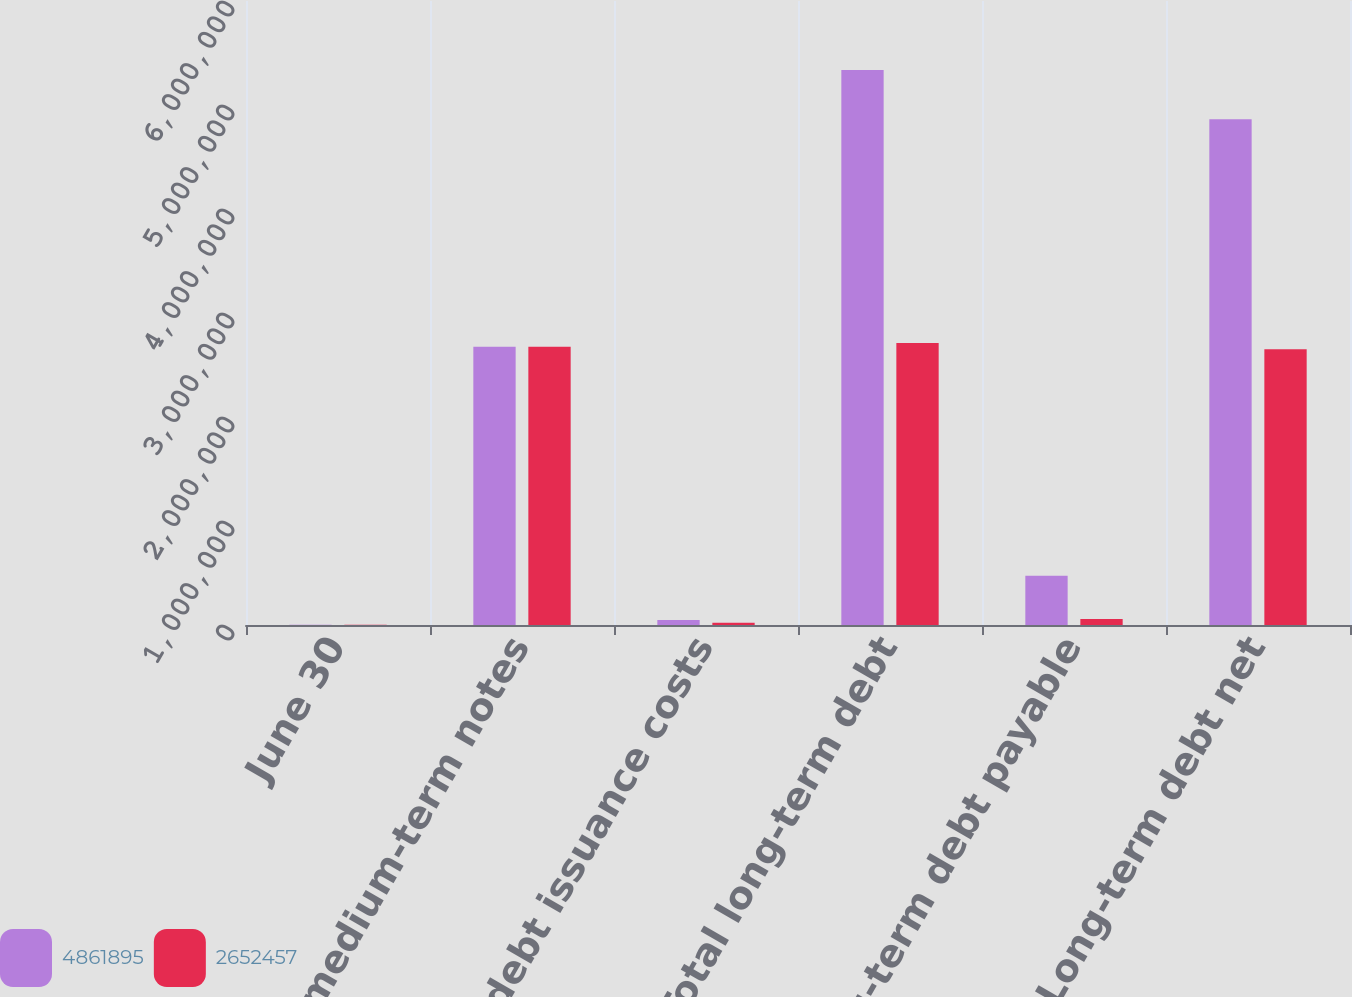<chart> <loc_0><loc_0><loc_500><loc_500><stacked_bar_chart><ecel><fcel>June 30<fcel>Fixed rate medium-term notes<fcel>Deferred debt issuance costs<fcel>Total long-term debt<fcel>Less Long-term debt payable<fcel>Long-term debt net<nl><fcel>4.8619e+06<fcel>2017<fcel>2.675e+06<fcel>47183<fcel>5.33616e+06<fcel>474265<fcel>4.8619e+06<nl><fcel>2.65246e+06<fcel>2016<fcel>2.675e+06<fcel>22596<fcel>2.71054e+06<fcel>58087<fcel>2.65246e+06<nl></chart> 